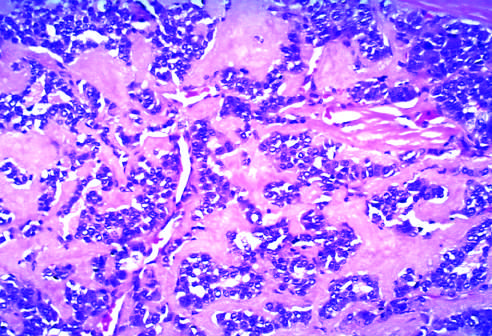what do these tumors contain?
Answer the question using a single word or phrase. Amyloid derived from calcitonin molecules secreted by the neoplastic cells 